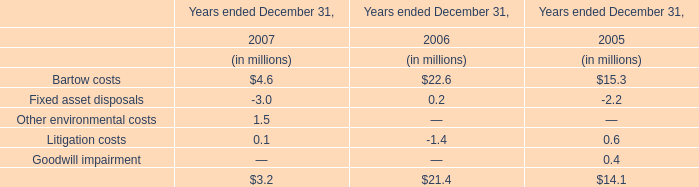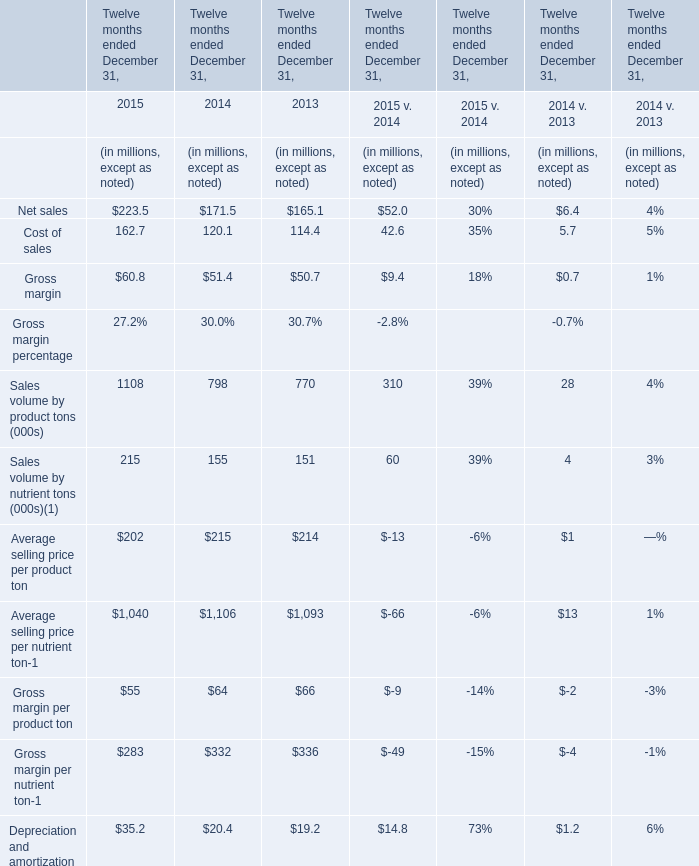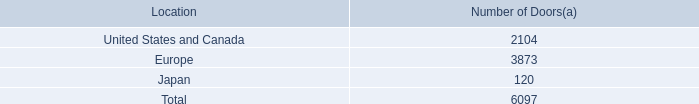In what year is Gross margin per nutrient ton greater than 333? 
Answer: 2013. 